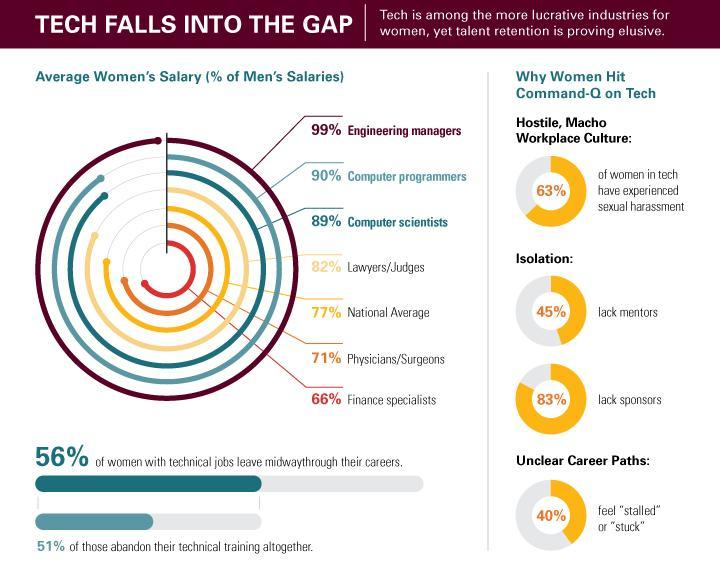What percentage of women in tech have not experienced sexual harassment?
Answer the question with a short phrase. 37% What percentage have sponsors? 17% What percentage have mentors? 55% What percentage of women with technical jobs have not left midway through their careers? 44% What percentage not feel stuck? 60% 